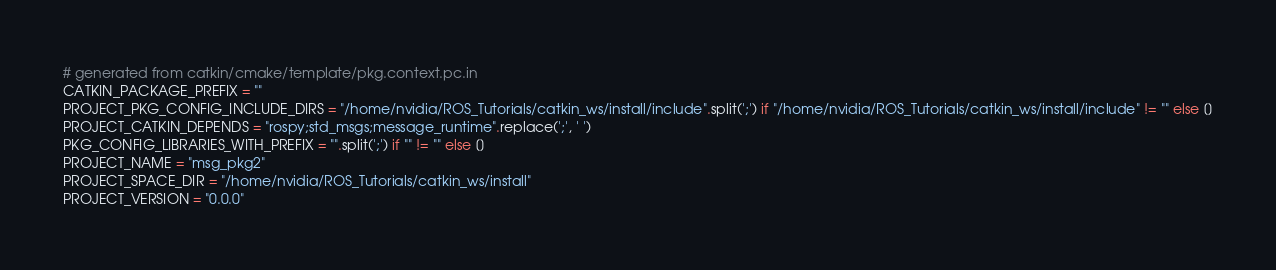<code> <loc_0><loc_0><loc_500><loc_500><_Python_># generated from catkin/cmake/template/pkg.context.pc.in
CATKIN_PACKAGE_PREFIX = ""
PROJECT_PKG_CONFIG_INCLUDE_DIRS = "/home/nvidia/ROS_Tutorials/catkin_ws/install/include".split(';') if "/home/nvidia/ROS_Tutorials/catkin_ws/install/include" != "" else []
PROJECT_CATKIN_DEPENDS = "rospy;std_msgs;message_runtime".replace(';', ' ')
PKG_CONFIG_LIBRARIES_WITH_PREFIX = "".split(';') if "" != "" else []
PROJECT_NAME = "msg_pkg2"
PROJECT_SPACE_DIR = "/home/nvidia/ROS_Tutorials/catkin_ws/install"
PROJECT_VERSION = "0.0.0"
</code> 